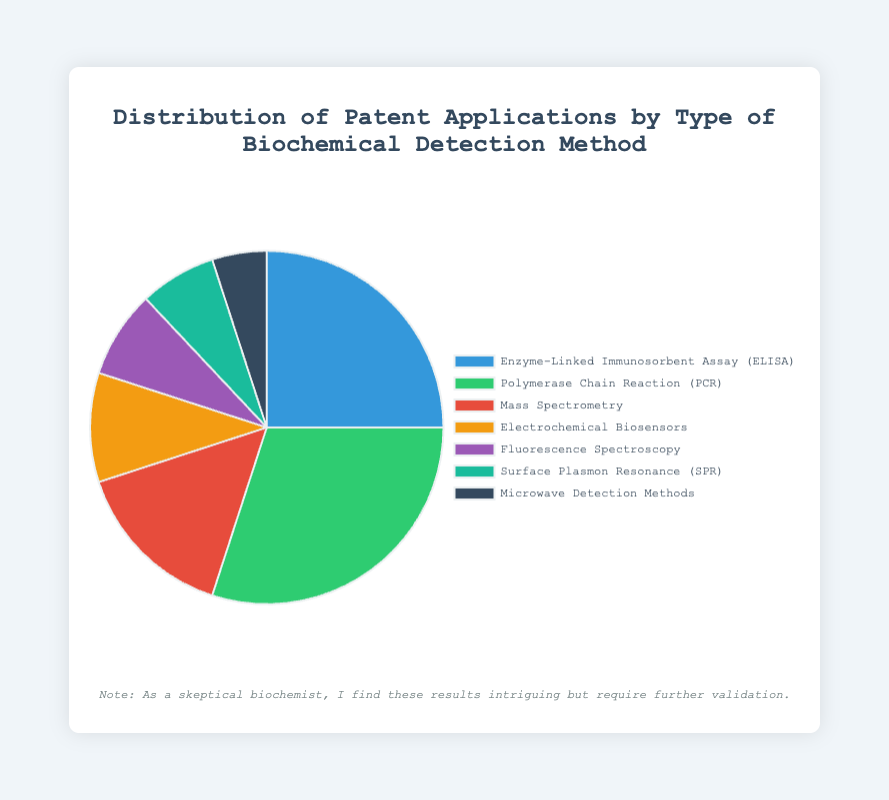Which biochemical detection method has the highest percentage of patent applications? The chart indicates that PCR has the highest portion in the pie chart
Answer: PCR How many percentage points greater is PCR than ELISA in patent applications? PCR is shown as 30% while ELISA is shown as 25%. Hence, 30% - 25% = 5%
Answer: 5% If we combine the percentages of Electrochemical Biosensors and Surface Plasmon Resonance (SPR), what is their total? Electrochemical Biosensors have 10% and SPR has 7%. Combined, they sum up to 10% + 7% = 17%
Answer: 17% What percentage of patent applications are accounted for by the methods with less than 10% each? Methods with less than 10% are Fluorescence Spectroscopy (8%), SPR (7%), and Microwave Detection Methods (5%). Summing these gives 8% + 7% + 5% = 20%
Answer: 20% How does the representation of Mass Spectrometry compare to that of Electrochemical Biosensors? Mass Spectrometry has 15% whereas Electrochemical Biosensors have 10%. 15% is greater than 10%
Answer: Mass Spectrometry Which method has the smallest portion, and what is its exact percentage? The chart shows Microwave Detection Methods as the smallest portion with 5%
Answer: Microwave Detection Methods What is the combined percentage share of the top three methods of biochemical detection? The top three methods are PCR (30%), ELISA (25%), and Mass Spectrometry (15%). Their combined percentage is 30% + 25% + 15% = 70%
Answer: 70% Which detection method is represented by the color nearest to purple on the pie chart? The methods shouldn't use coding terms like hex codes, instead, note the color that visually matches. Fluorescence Spectroscopy is shown in purple.
Answer: Fluorescence Spectroscopy 